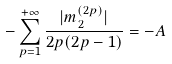Convert formula to latex. <formula><loc_0><loc_0><loc_500><loc_500>- \sum _ { p = 1 } ^ { + \infty } \frac { | m _ { 2 } ^ { ( 2 p ) } | } { 2 p ( 2 p - 1 ) } = - A</formula> 